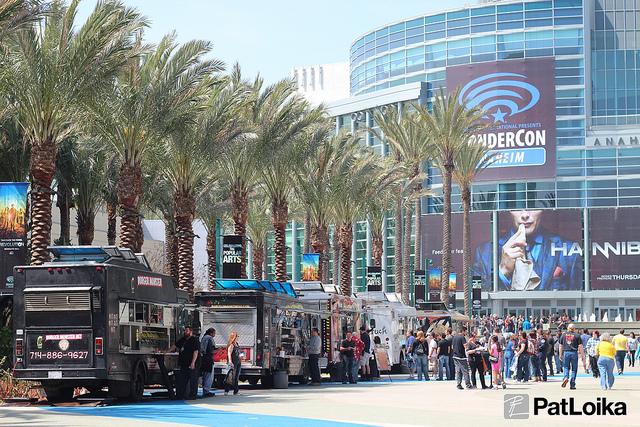Is it day time in this photo?
Quick response, please. Yes. Where is this?
Be succinct. Anaheim. What popular brand is seen in this image?
Short answer required. Hannibal. Are yellow buildings?
Keep it brief. No. What type of products are available for purchase in this market?
Give a very brief answer. Food. Is it nighttime?
Keep it brief. No. Are there any advertisement boars on the building?
Short answer required. Yes. Are there food trucks?
Write a very short answer. Yes. 